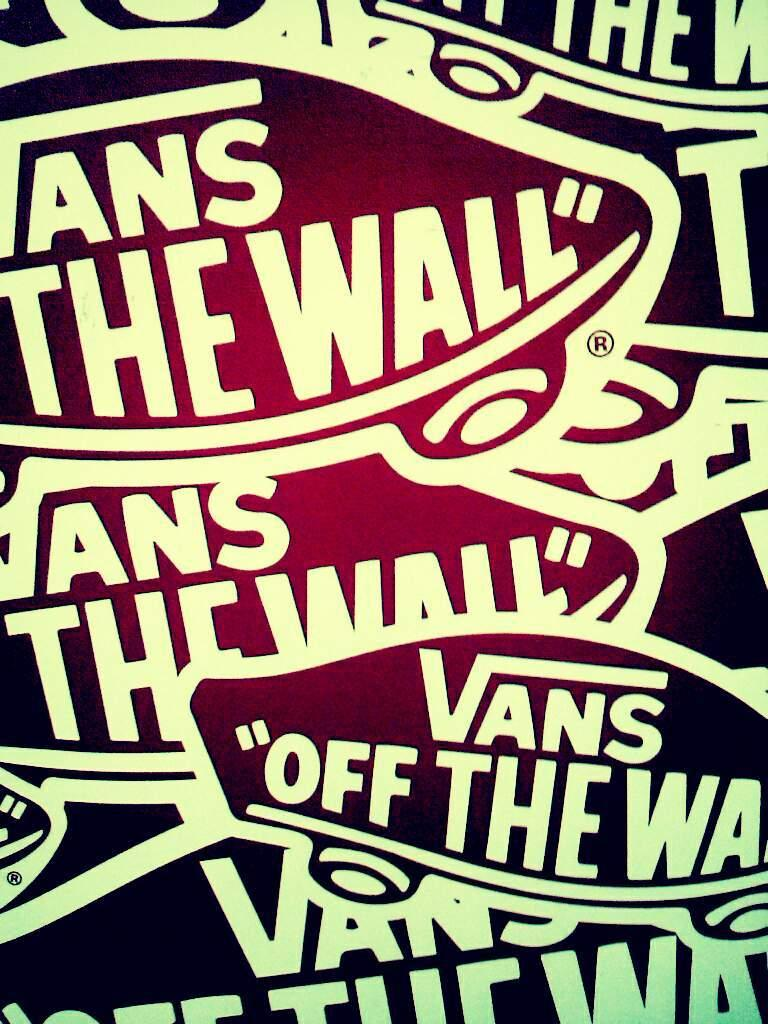<image>
Create a compact narrative representing the image presented. an ad for vans off the wall skateboards 